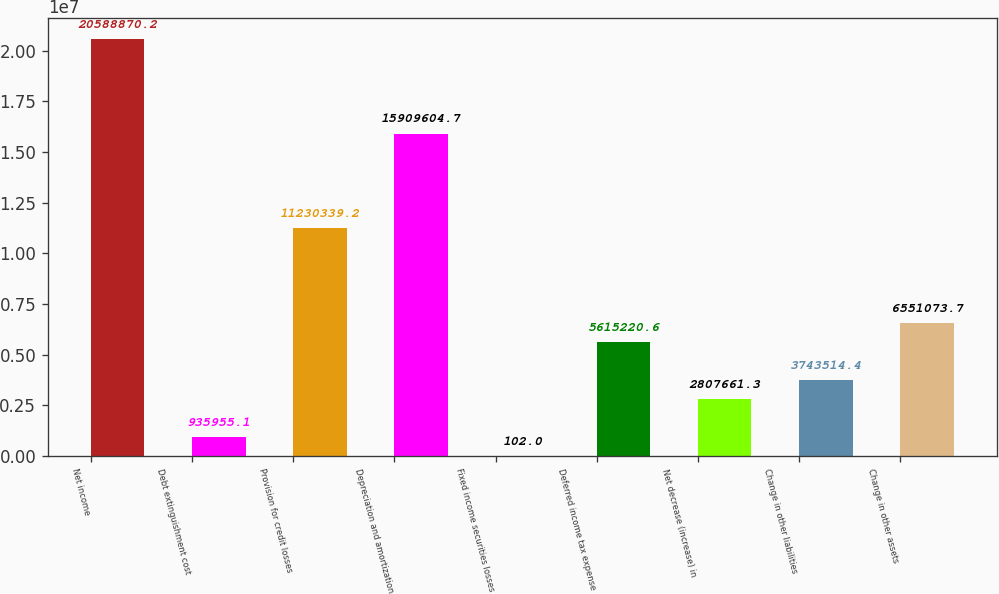<chart> <loc_0><loc_0><loc_500><loc_500><bar_chart><fcel>Net income<fcel>Debt extinguishment cost<fcel>Provision for credit losses<fcel>Depreciation and amortization<fcel>Fixed income securities losses<fcel>Deferred income tax expense<fcel>Net decrease (increase) in<fcel>Change in other liabilities<fcel>Change in other assets<nl><fcel>2.05889e+07<fcel>935955<fcel>1.12303e+07<fcel>1.59096e+07<fcel>102<fcel>5.61522e+06<fcel>2.80766e+06<fcel>3.74351e+06<fcel>6.55107e+06<nl></chart> 